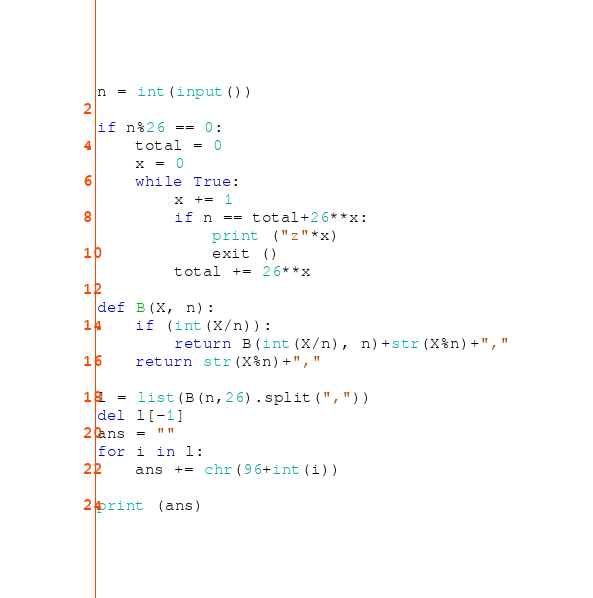<code> <loc_0><loc_0><loc_500><loc_500><_Python_>n = int(input())

if n%26 == 0:
    total = 0
    x = 0
    while True:
        x += 1
        if n == total+26**x:
            print ("z"*x)
            exit ()
        total += 26**x

def B(X, n):
    if (int(X/n)):
        return B(int(X/n), n)+str(X%n)+","
    return str(X%n)+","

l = list(B(n,26).split(","))
del l[-1]
ans = ""
for i in l:
    ans += chr(96+int(i))

print (ans)
</code> 